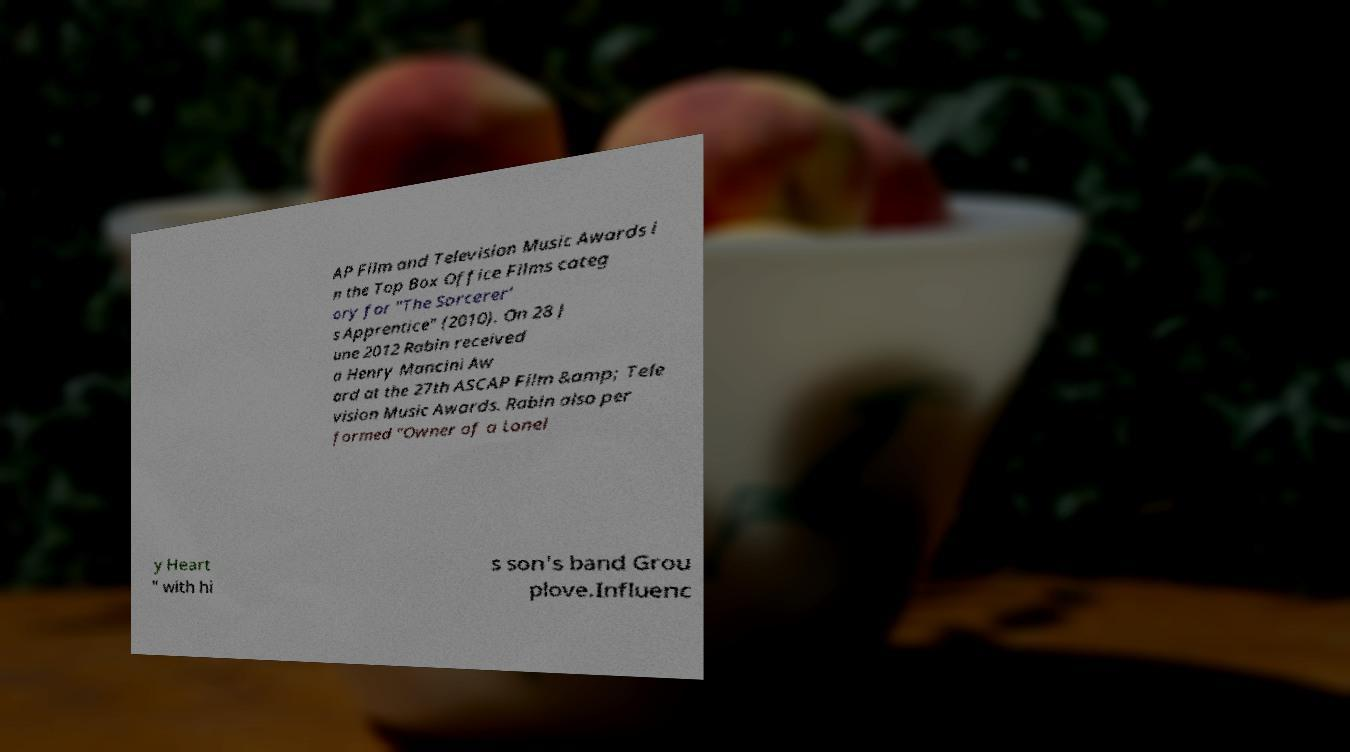I need the written content from this picture converted into text. Can you do that? AP Film and Television Music Awards i n the Top Box Office Films categ ory for "The Sorcerer' s Apprentice" (2010). On 28 J une 2012 Rabin received a Henry Mancini Aw ard at the 27th ASCAP Film &amp; Tele vision Music Awards. Rabin also per formed "Owner of a Lonel y Heart " with hi s son's band Grou plove.Influenc 